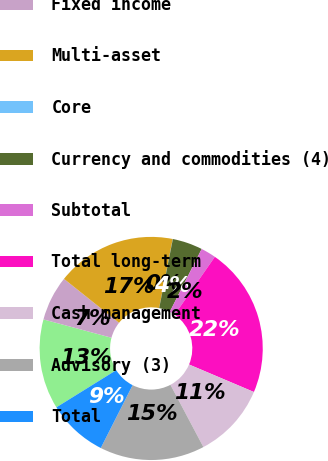Convert chart to OTSL. <chart><loc_0><loc_0><loc_500><loc_500><pie_chart><fcel>Equity<fcel>Fixed income<fcel>Multi-asset<fcel>Core<fcel>Currency and commodities (4)<fcel>Subtotal<fcel>Total long-term<fcel>Cash management<fcel>Advisory (3)<fcel>Total<nl><fcel>13.04%<fcel>6.53%<fcel>17.38%<fcel>0.02%<fcel>4.36%<fcel>2.19%<fcel>21.72%<fcel>10.87%<fcel>15.21%<fcel>8.7%<nl></chart> 